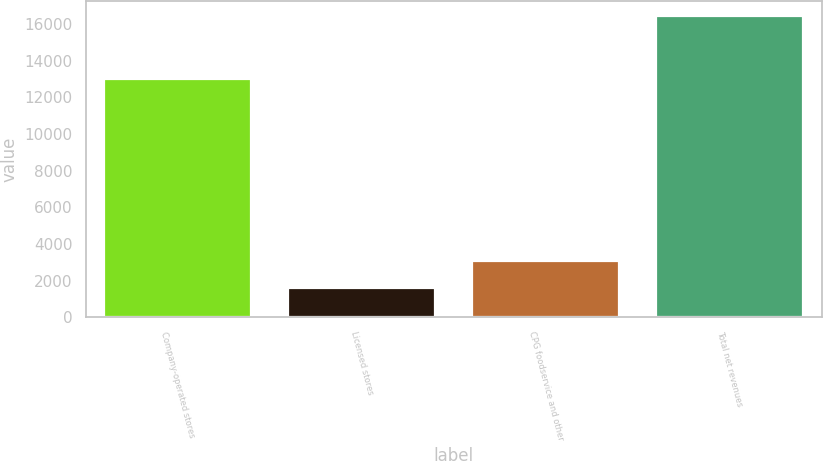Convert chart to OTSL. <chart><loc_0><loc_0><loc_500><loc_500><bar_chart><fcel>Company-operated stores<fcel>Licensed stores<fcel>CPG foodservice and other<fcel>Total net revenues<nl><fcel>12977.9<fcel>1588.6<fcel>3074.52<fcel>16447.8<nl></chart> 